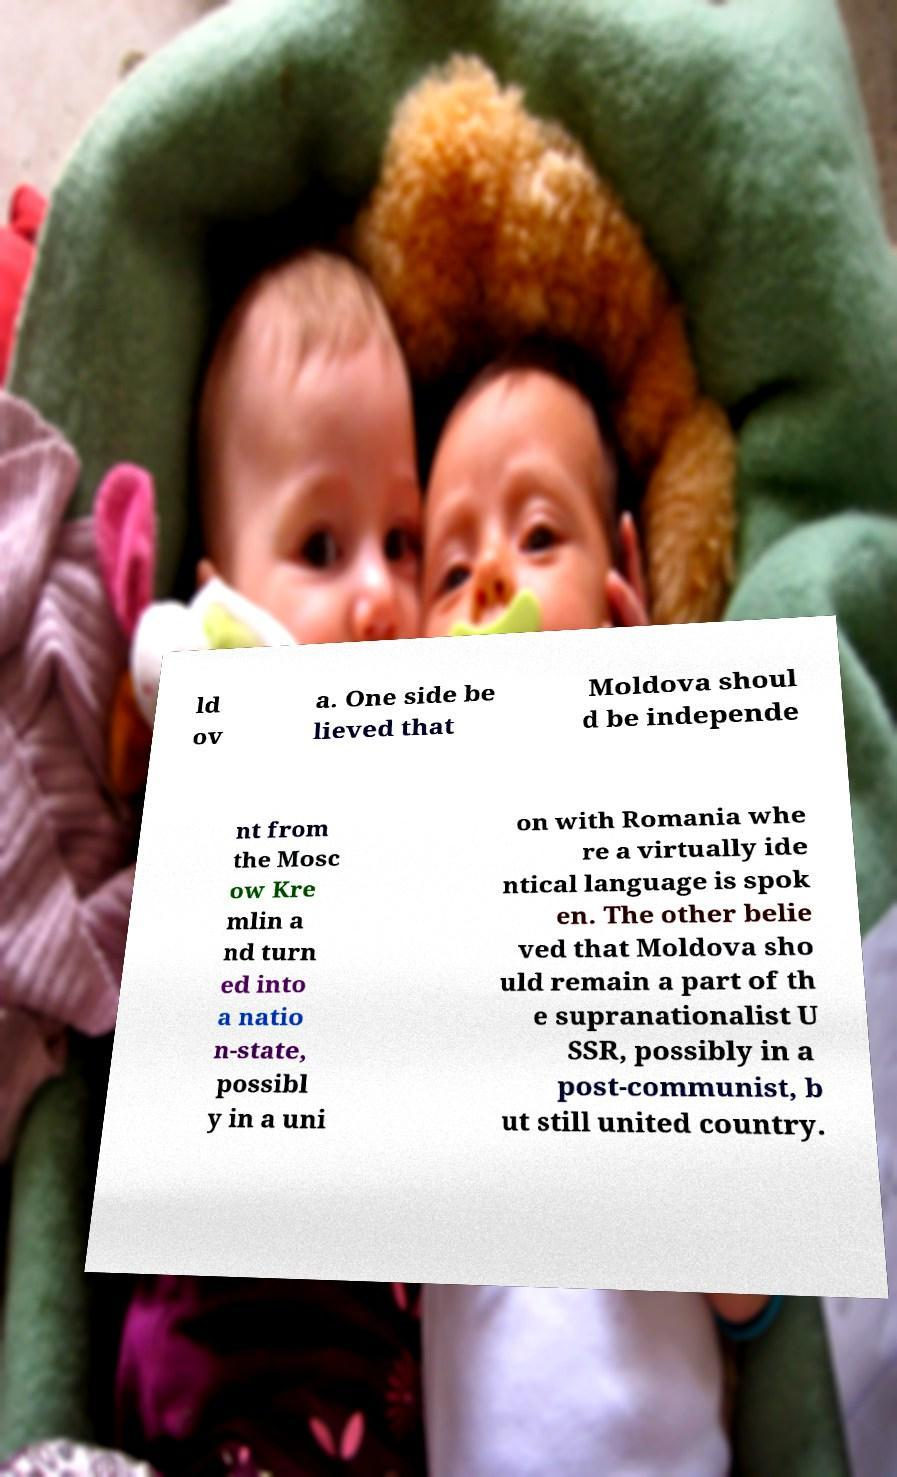Please identify and transcribe the text found in this image. ld ov a. One side be lieved that Moldova shoul d be independe nt from the Mosc ow Kre mlin a nd turn ed into a natio n-state, possibl y in a uni on with Romania whe re a virtually ide ntical language is spok en. The other belie ved that Moldova sho uld remain a part of th e supranationalist U SSR, possibly in a post-communist, b ut still united country. 